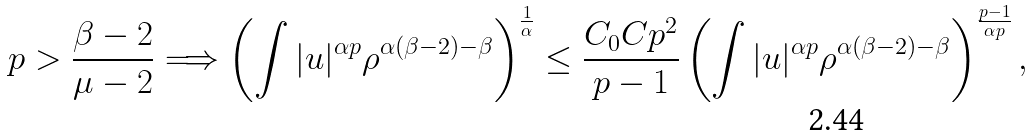<formula> <loc_0><loc_0><loc_500><loc_500>p > \frac { \beta - 2 } { \mu - 2 } \Longrightarrow \left ( \int | u | ^ { \alpha p } \rho ^ { \alpha ( \beta - 2 ) - \beta } \right ) ^ { \frac { 1 } { \alpha } } \leq \frac { C _ { 0 } C p ^ { 2 } } { p - 1 } \left ( \int | u | ^ { \alpha p } \rho ^ { \alpha ( \beta - 2 ) - \beta } \right ) ^ { \frac { p - 1 } { \alpha p } } ,</formula> 